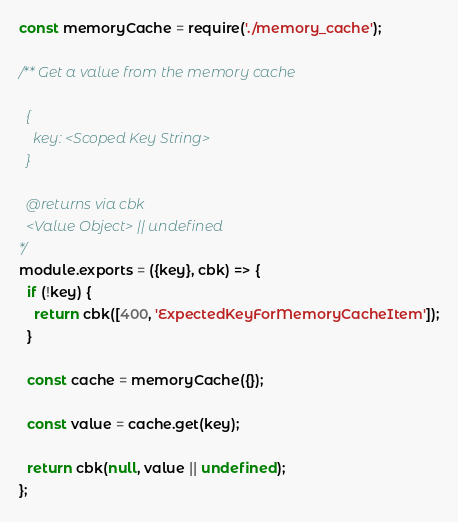<code> <loc_0><loc_0><loc_500><loc_500><_JavaScript_>const memoryCache = require('./memory_cache');

/** Get a value from the memory cache

  {
    key: <Scoped Key String>
  }

  @returns via cbk
  <Value Object> || undefined
*/
module.exports = ({key}, cbk) => {
  if (!key) {
    return cbk([400, 'ExpectedKeyForMemoryCacheItem']);
  }

  const cache = memoryCache({});

  const value = cache.get(key);

  return cbk(null, value || undefined);
};
</code> 